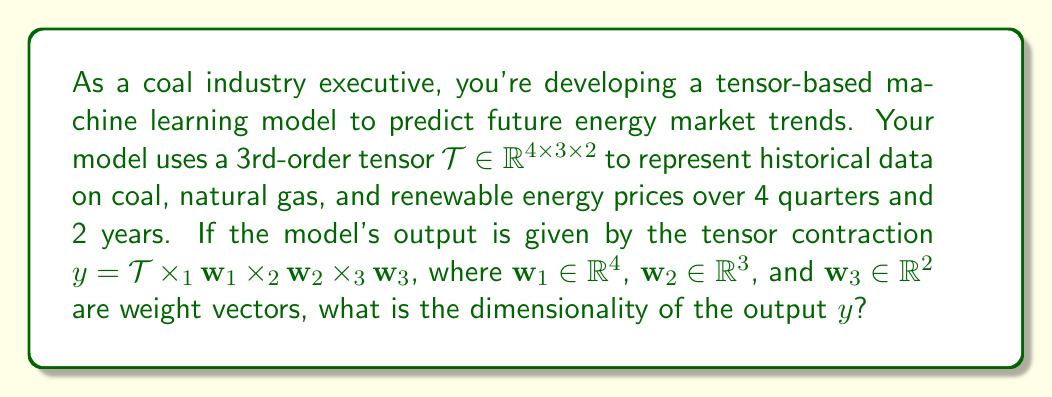Show me your answer to this math problem. Let's approach this step-by-step:

1) We start with a 3rd-order tensor $\mathcal{T} \in \mathbb{R}^{4 \times 3 \times 2}$.

2) The output $y$ is obtained by contracting this tensor along all three modes with weight vectors:
   $y = \mathcal{T} \times_1 \mathbf{w}_1 \times_2 \mathbf{w}_2 \times_3 \mathbf{w}_3$

3) Let's consider each contraction:

   a) $\mathcal{T} \times_1 \mathbf{w}_1$:
      - $\mathcal{T}$ has shape $(4 \times 3 \times 2)$
      - $\mathbf{w}_1$ has shape $(4)$
      - Result: $(3 \times 2)$ tensor

   b) $(\mathcal{T} \times_1 \mathbf{w}_1) \times_2 \mathbf{w}_2$:
      - Input has shape $(3 \times 2)$
      - $\mathbf{w}_2$ has shape $(3)$
      - Result: $(2)$ vector

   c) $((\mathcal{T} \times_1 \mathbf{w}_1) \times_2 \mathbf{w}_2) \times_3 \mathbf{w}_3$:
      - Input has shape $(2)$
      - $\mathbf{w}_3$ has shape $(2)$
      - Result: scalar

4) Therefore, after all contractions, we end up with a scalar value.

In tensor notation, we can write this as:

$$y = \sum_{i=1}^4 \sum_{j=1}^3 \sum_{k=1}^2 \mathcal{T}_{ijk} \cdot (\mathbf{w}_1)_i \cdot (\mathbf{w}_2)_j \cdot (\mathbf{w}_3)_k$$

This results in a single number, which represents the model's prediction for future energy market trends.
Answer: Scalar (0-dimensional) 